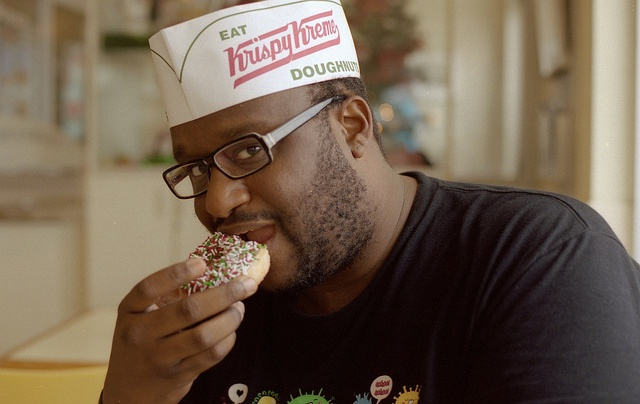Describe the objects in this image and their specific colors. I can see people in olive, black, maroon, and gray tones and donut in olive, darkgray, maroon, gray, and tan tones in this image. 